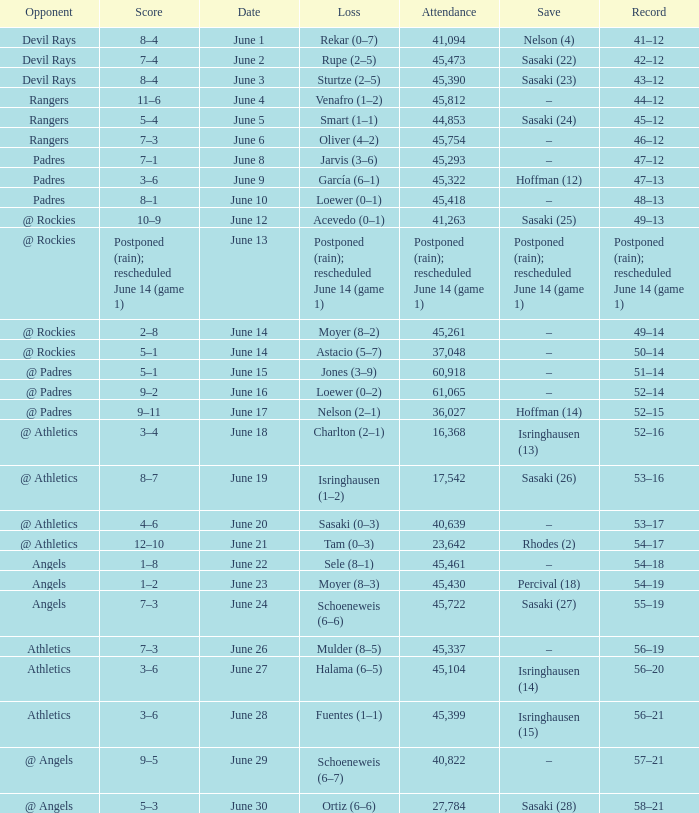What was the score of the Mariners game when they had a record of 56–21? 3–6. 